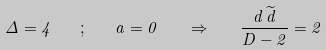<formula> <loc_0><loc_0><loc_500><loc_500>\Delta = 4 \quad ; \quad a = 0 \quad \Rightarrow \quad \frac { d \, \widetilde { d } } { D - 2 } = 2</formula> 